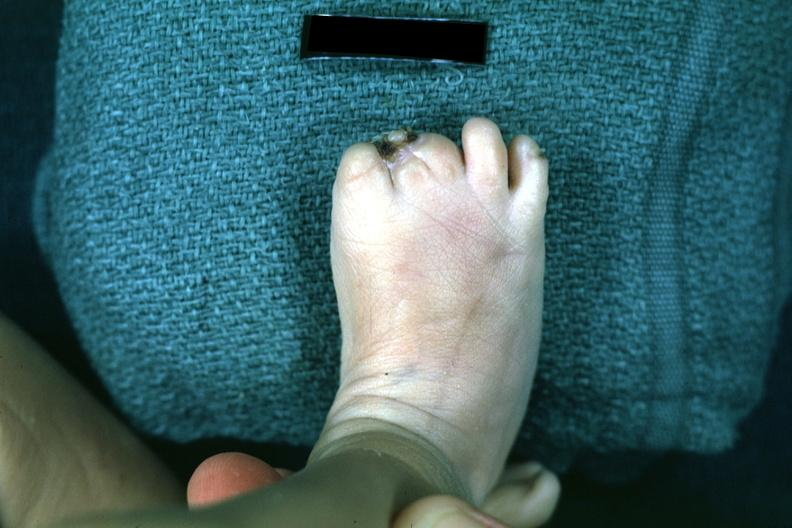re extremities present?
Answer the question using a single word or phrase. Yes 